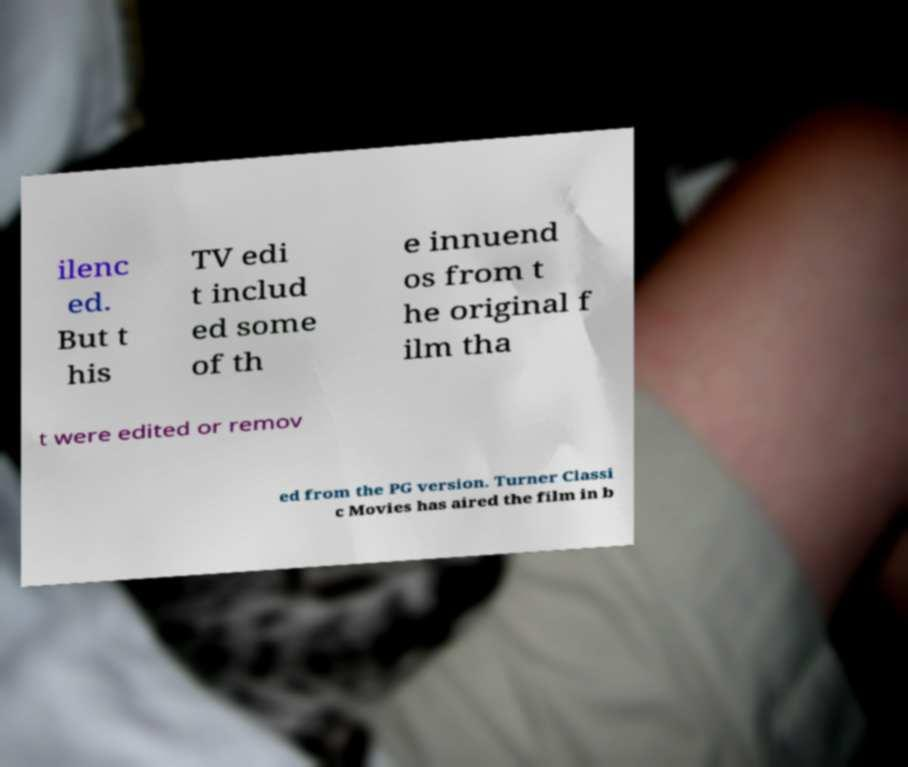Could you assist in decoding the text presented in this image and type it out clearly? ilenc ed. But t his TV edi t includ ed some of th e innuend os from t he original f ilm tha t were edited or remov ed from the PG version. Turner Classi c Movies has aired the film in b 